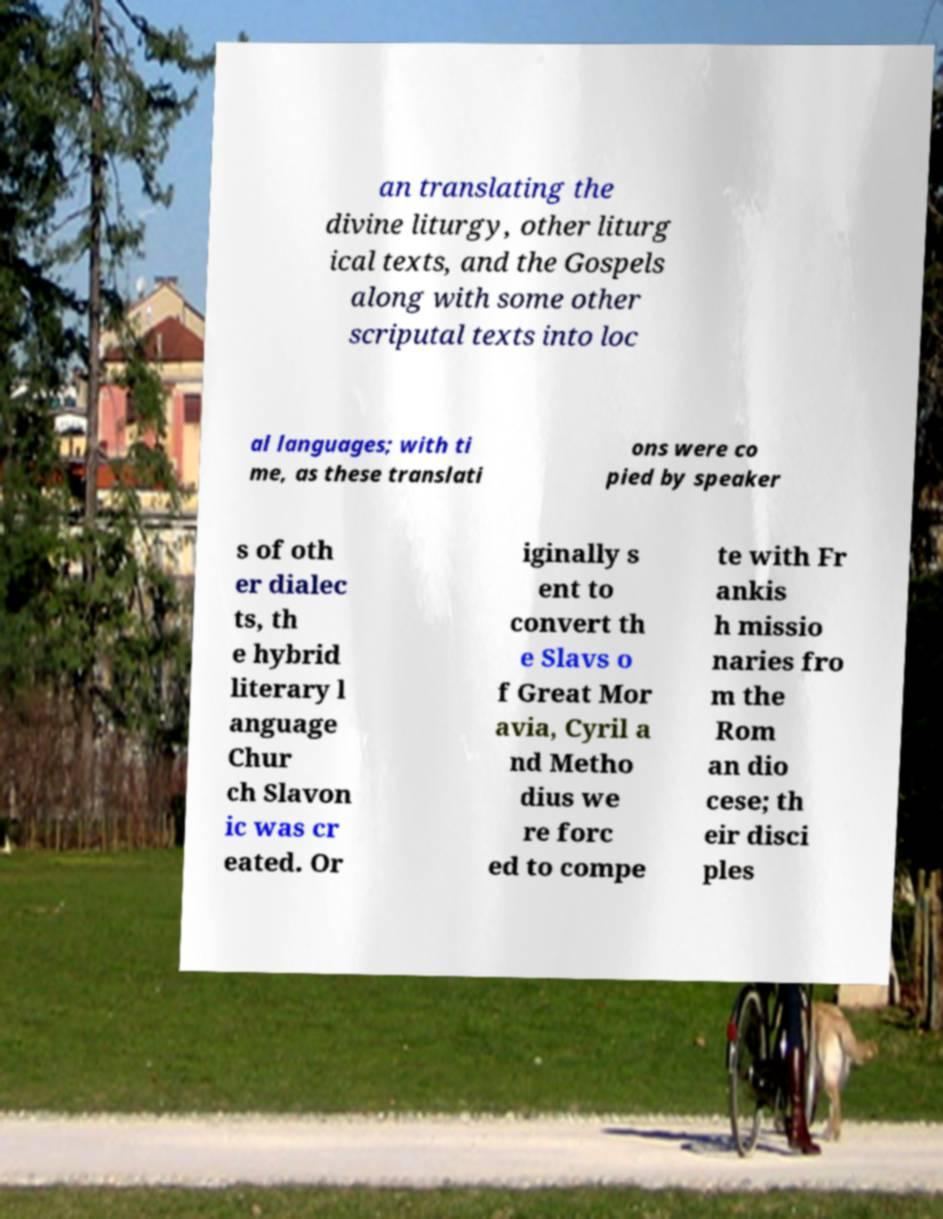For documentation purposes, I need the text within this image transcribed. Could you provide that? an translating the divine liturgy, other liturg ical texts, and the Gospels along with some other scriputal texts into loc al languages; with ti me, as these translati ons were co pied by speaker s of oth er dialec ts, th e hybrid literary l anguage Chur ch Slavon ic was cr eated. Or iginally s ent to convert th e Slavs o f Great Mor avia, Cyril a nd Metho dius we re forc ed to compe te with Fr ankis h missio naries fro m the Rom an dio cese; th eir disci ples 